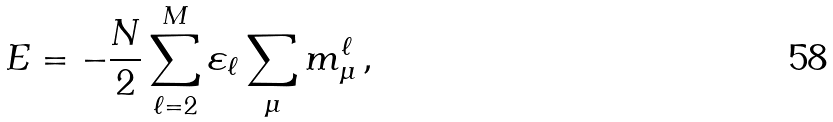<formula> <loc_0><loc_0><loc_500><loc_500>E = - \frac { N } { 2 } \sum _ { \ell = 2 } ^ { M } \varepsilon _ { \ell } \sum _ { \mu } m _ { \mu } ^ { \ell } \, ,</formula> 